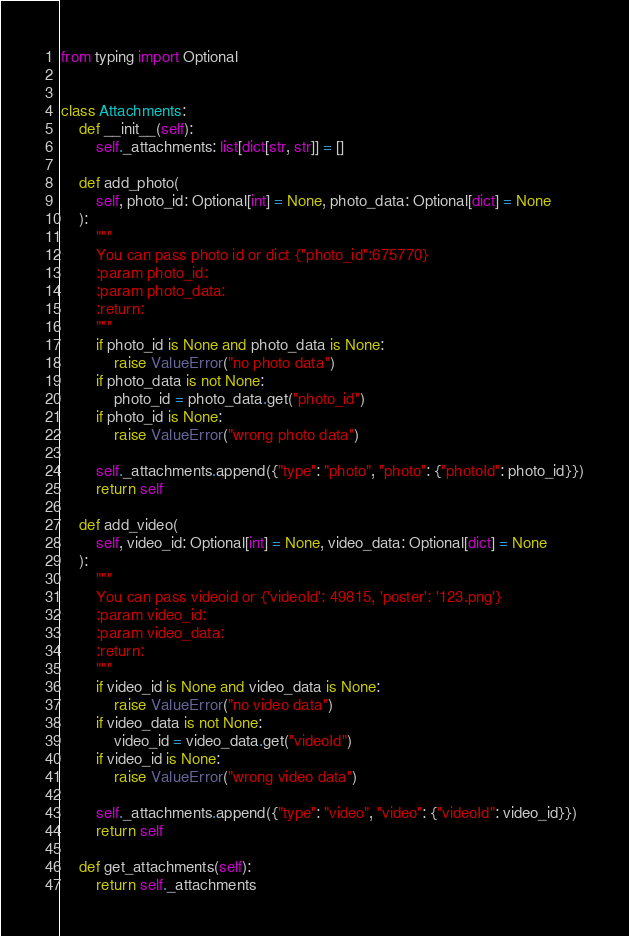<code> <loc_0><loc_0><loc_500><loc_500><_Python_>from typing import Optional


class Attachments:
    def __init__(self):
        self._attachments: list[dict[str, str]] = []

    def add_photo(
        self, photo_id: Optional[int] = None, photo_data: Optional[dict] = None
    ):
        """
        You can pass photo id or dict {"photo_id":675770}
        :param photo_id:
        :param photo_data:
        :return:
        """
        if photo_id is None and photo_data is None:
            raise ValueError("no photo data")
        if photo_data is not None:
            photo_id = photo_data.get("photo_id")
        if photo_id is None:
            raise ValueError("wrong photo data")

        self._attachments.append({"type": "photo", "photo": {"photoId": photo_id}})
        return self

    def add_video(
        self, video_id: Optional[int] = None, video_data: Optional[dict] = None
    ):
        """
        You can pass videoid or {'videoId': 49815, 'poster': '123.png'} 
        :param video_id:
        :param video_data:
        :return:
        """
        if video_id is None and video_data is None:
            raise ValueError("no video data")
        if video_data is not None:
            video_id = video_data.get("videoId")
        if video_id is None:
            raise ValueError("wrong video data")

        self._attachments.append({"type": "video", "video": {"videoId": video_id}})
        return self

    def get_attachments(self):
        return self._attachments</code> 